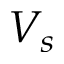Convert formula to latex. <formula><loc_0><loc_0><loc_500><loc_500>V _ { s }</formula> 